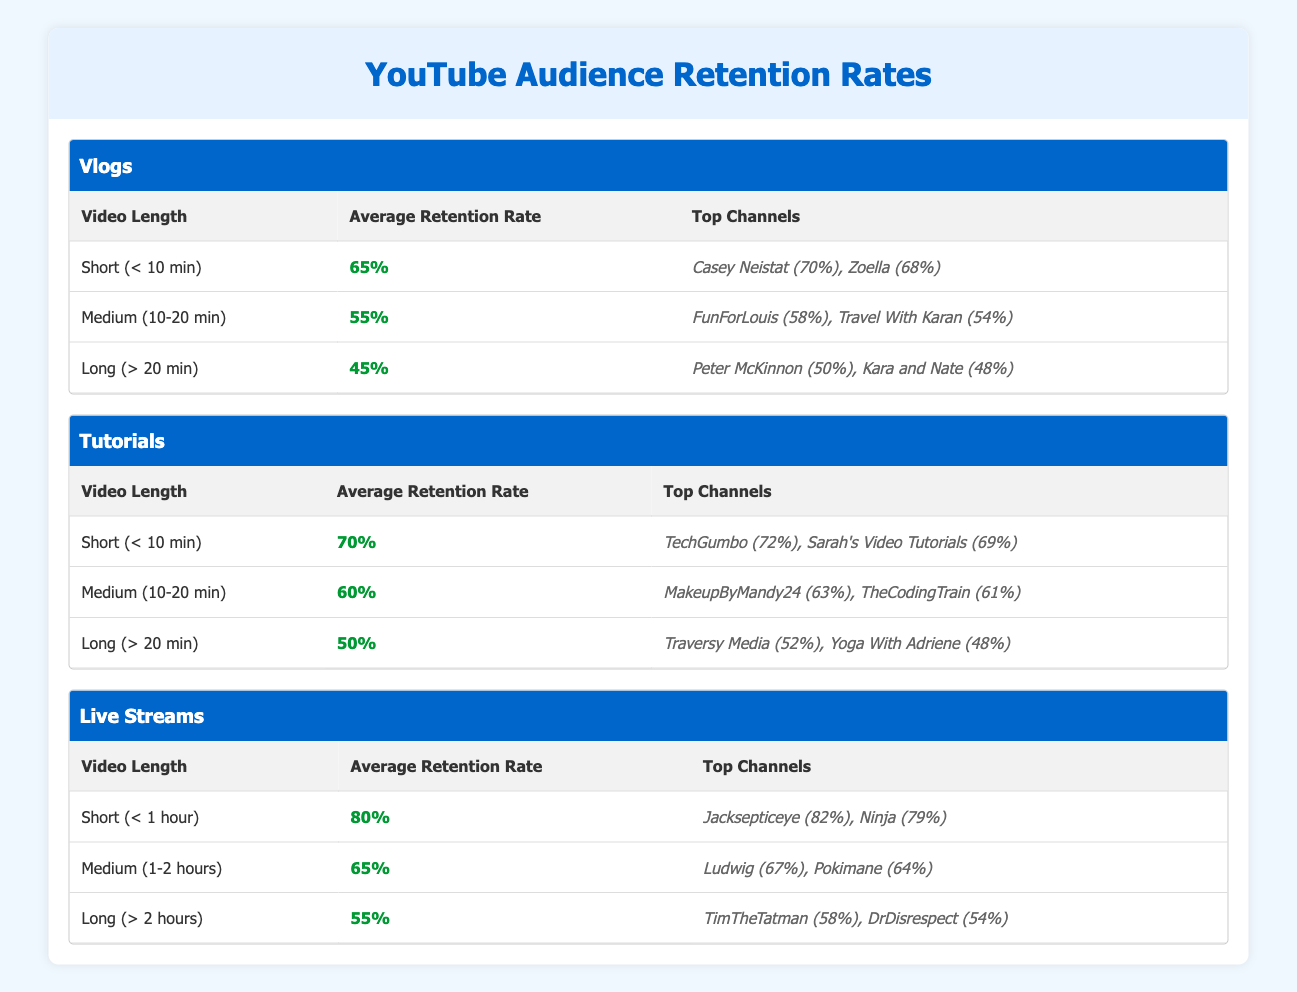What is the average retention rate for short Vlogs? The average retention rate for short Vlogs is provided in the table under the "Average Retention Rate" column for the "Short (< 10 min)" row. It states that the average retention rate is 65%.
Answer: 65% Which format has the highest average retention rate for video lengths under 10 minutes? Looking at the table, we find that the average retention rate for short Vlogs is 65% and for short Tutorials is 70%. Comparing these, short Tutorials has the highest average retention rate.
Answer: Tutorials What is the difference in average retention rates between medium-length Vlogs and Tutorials? The average retention rate for medium (10-20 min) Vlogs is 55%, whereas for medium Tutorials it is 60%. Calculating the difference: 60% - 55% = 5%.
Answer: 5% Is it true that short Live Streams have a higher average retention rate than long Vlogs? The average retention rate for short Live Streams is 80%, and for long Vlogs, it is 45%. Since 80% is greater than 45%, the statement is true.
Answer: Yes Which channel has the highest retention rate for medium-length Tutorials? In the Tutorials section, for medium (10-20 min), the top channels listed with their retention rates indicate that MakeupByMandy24 has the highest retention rate of 63%.
Answer: MakeupByMandy24 What is the average retention rate for long Live Streams? The average retention rate for long Live Streams (> 2 hours) is displayed in the "Average Retention Rate" column for the corresponding row. It states the average is 55%.
Answer: 55% Which format has the lowest average retention rate for long videos? From the table, we see that for long videos, Vlogs have an average retention rate of 45%, Tutorials have 50%, and Live Streams have 55%. The lowest is Vlogs with 45%.
Answer: Vlogs If we consider all formats for short video lengths, what is the average retention rate? The average retention rates for short videos are: Vlogs 65%, Tutorials 70%, and Live Streams 80%. Adding these up gives 65% + 70% + 80% = 215%. Dividing by 3 for the average: 215% / 3 = 71.67%.
Answer: 71.67% Which channels together have the top two retention rates for short Vlogs? The top channels for short Vlogs listed in the table are Casey Neistat with a retention rate of 70% and Zoella with a retention rate of 68%. Together, they represent the top two channels for that category.
Answer: Casey Neistat, Zoella 